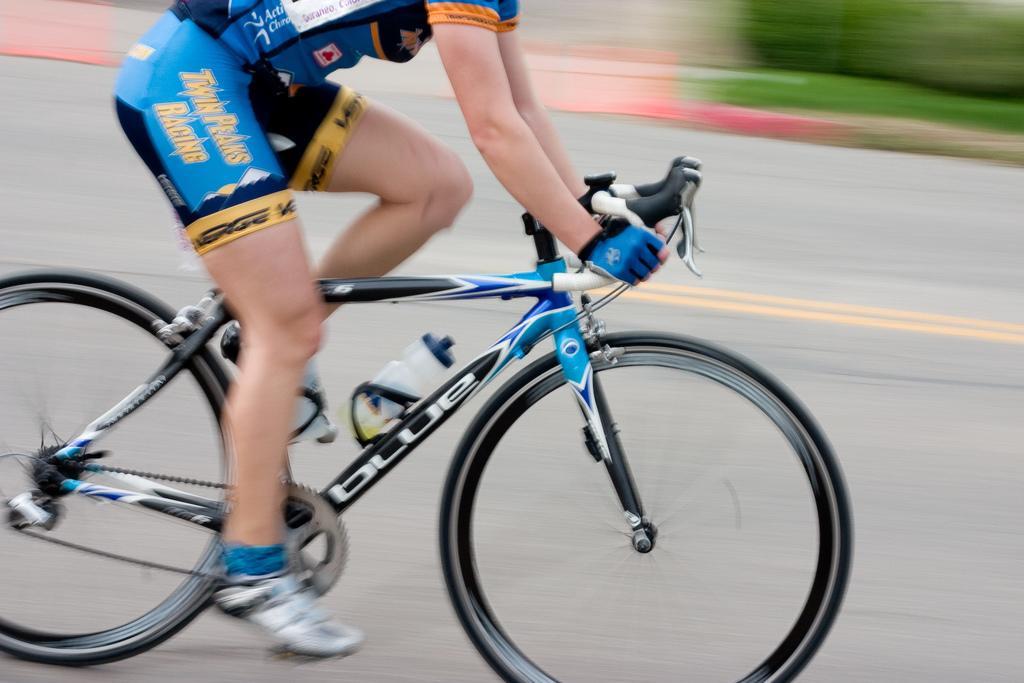Could you give a brief overview of what you see in this image? In this image we can see a person riding bicycle on the road. On the backside we can see some plants. 